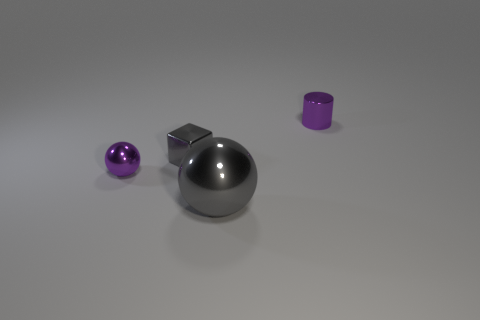The object that is the same color as the shiny cube is what size?
Your answer should be compact. Large. What number of things are balls that are right of the tiny shiny block or purple metal objects that are on the right side of the metallic cube?
Your response must be concise. 2. There is a purple metal object left of the purple object behind the purple metal sphere; what is its shape?
Your response must be concise. Sphere. Are there any yellow spheres made of the same material as the block?
Keep it short and to the point. No. What color is the other object that is the same shape as the big object?
Your answer should be very brief. Purple. Are there fewer small gray cubes that are behind the small purple cylinder than purple things on the right side of the tiny purple sphere?
Provide a short and direct response. Yes. How many other things are there of the same shape as the big gray metallic object?
Keep it short and to the point. 1. Is the number of cubes behind the purple shiny cylinder less than the number of tiny gray rubber cubes?
Your answer should be very brief. No. How many other things are the same size as the gray cube?
Give a very brief answer. 2. Is the number of purple things less than the number of large cylinders?
Your answer should be compact. No. 